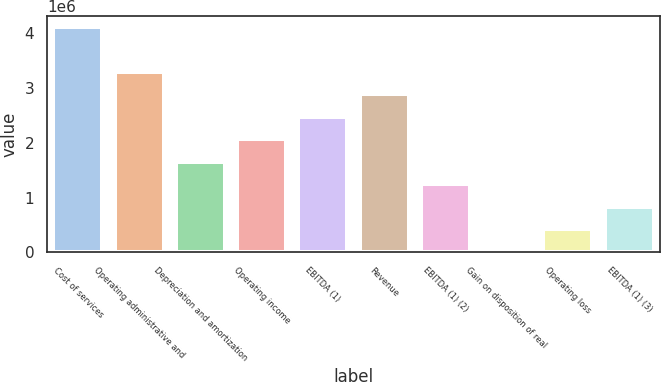Convert chart. <chart><loc_0><loc_0><loc_500><loc_500><bar_chart><fcel>Cost of services<fcel>Operating administrative and<fcel>Depreciation and amortization<fcel>Operating income<fcel>EBITDA (1)<fcel>Revenue<fcel>EBITDA (1) (2)<fcel>Gain on disposition of real<fcel>Operating loss<fcel>EBITDA (1) (3)<nl><fcel>4.11626e+06<fcel>3.29516e+06<fcel>1.65297e+06<fcel>2.06351e+06<fcel>2.47406e+06<fcel>2.88461e+06<fcel>1.24242e+06<fcel>10771<fcel>421320<fcel>831868<nl></chart> 